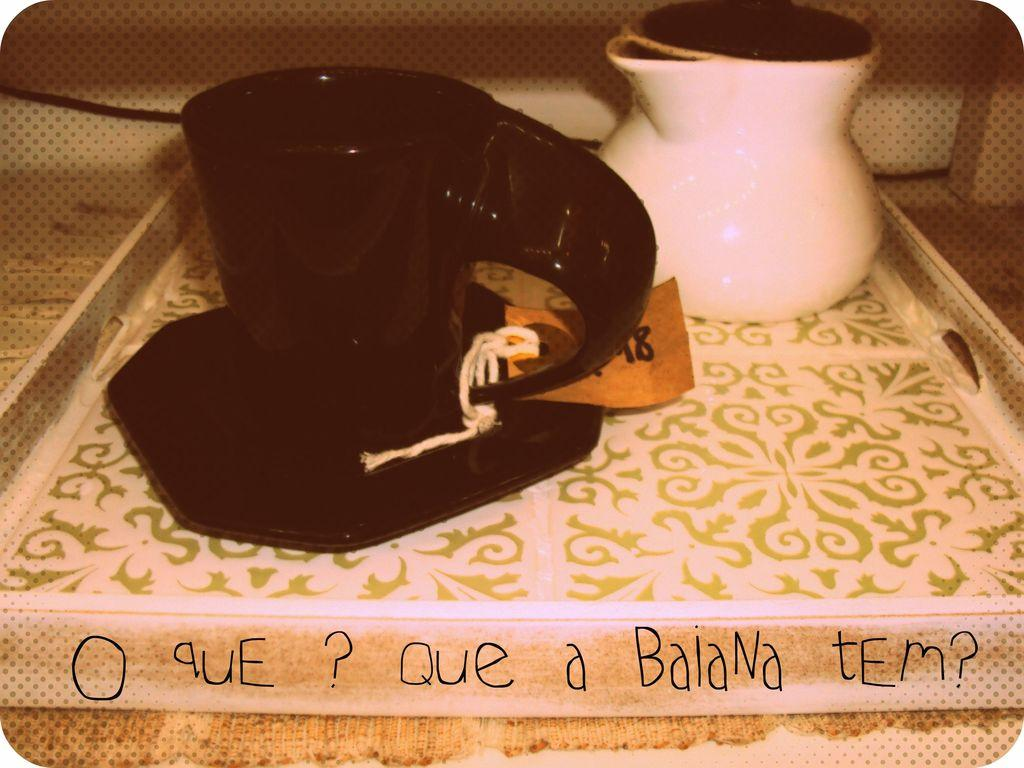What type of container is present in the image? There is a cup in the image. What other item is related to the cup in the image? There is a saucer in the image. What additional item can be seen in the image? There is a jar in the image. How are these items arranged in the image? The items are on a tray. What is written on the tray? There is text on the tray. Is there any other detail related to the cup? A tag is tied to the cup. How many cows are visible in the image? There are no cows present in the image. What year is depicted on the tag tied to the cup? The tag tied to the cup does not have any year mentioned in the image. 